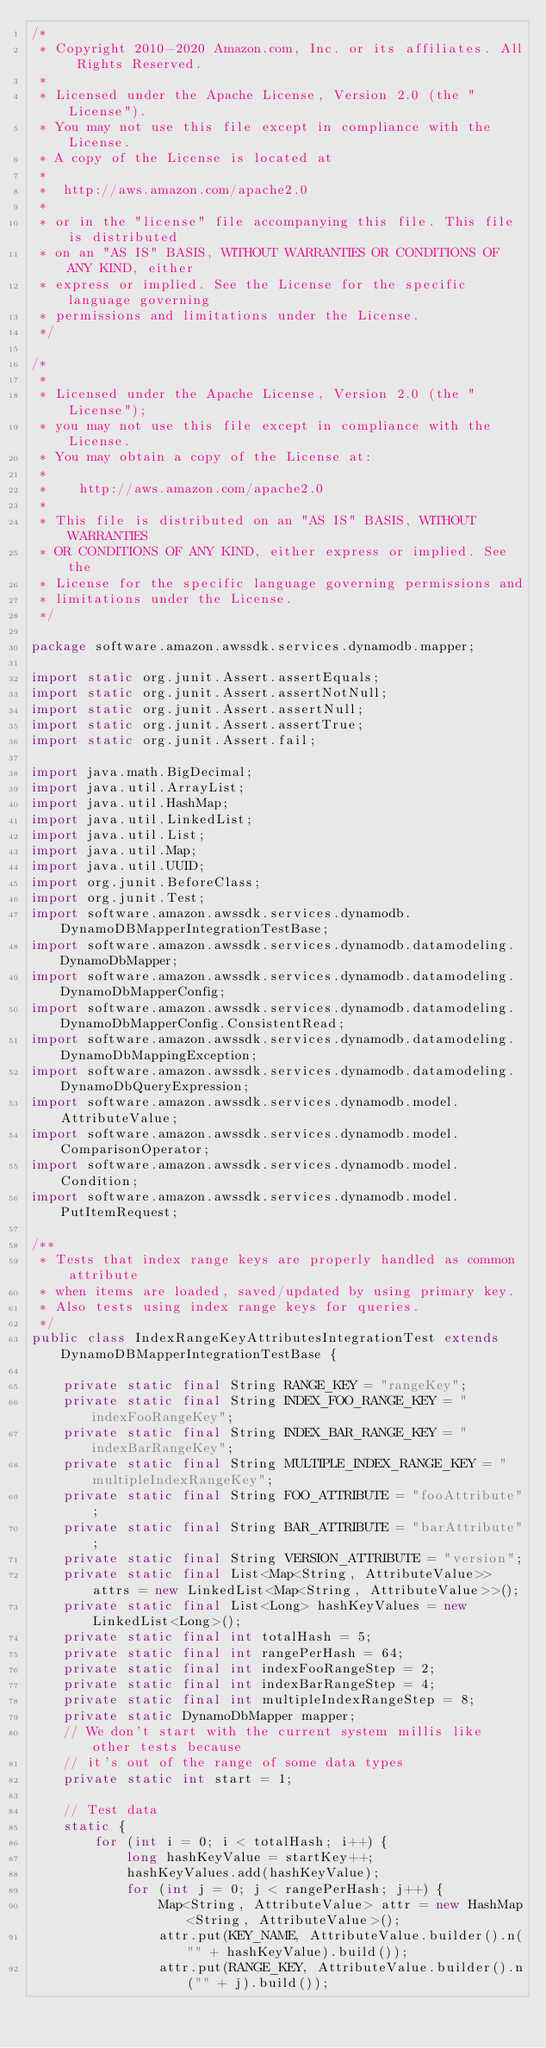Convert code to text. <code><loc_0><loc_0><loc_500><loc_500><_Java_>/*
 * Copyright 2010-2020 Amazon.com, Inc. or its affiliates. All Rights Reserved.
 *
 * Licensed under the Apache License, Version 2.0 (the "License").
 * You may not use this file except in compliance with the License.
 * A copy of the License is located at
 *
 *  http://aws.amazon.com/apache2.0
 *
 * or in the "license" file accompanying this file. This file is distributed
 * on an "AS IS" BASIS, WITHOUT WARRANTIES OR CONDITIONS OF ANY KIND, either
 * express or implied. See the License for the specific language governing
 * permissions and limitations under the License.
 */

/*
 *
 * Licensed under the Apache License, Version 2.0 (the "License");
 * you may not use this file except in compliance with the License.
 * You may obtain a copy of the License at:
 *
 *    http://aws.amazon.com/apache2.0
 *
 * This file is distributed on an "AS IS" BASIS, WITHOUT WARRANTIES
 * OR CONDITIONS OF ANY KIND, either express or implied. See the
 * License for the specific language governing permissions and
 * limitations under the License.
 */

package software.amazon.awssdk.services.dynamodb.mapper;

import static org.junit.Assert.assertEquals;
import static org.junit.Assert.assertNotNull;
import static org.junit.Assert.assertNull;
import static org.junit.Assert.assertTrue;
import static org.junit.Assert.fail;

import java.math.BigDecimal;
import java.util.ArrayList;
import java.util.HashMap;
import java.util.LinkedList;
import java.util.List;
import java.util.Map;
import java.util.UUID;
import org.junit.BeforeClass;
import org.junit.Test;
import software.amazon.awssdk.services.dynamodb.DynamoDBMapperIntegrationTestBase;
import software.amazon.awssdk.services.dynamodb.datamodeling.DynamoDbMapper;
import software.amazon.awssdk.services.dynamodb.datamodeling.DynamoDbMapperConfig;
import software.amazon.awssdk.services.dynamodb.datamodeling.DynamoDbMapperConfig.ConsistentRead;
import software.amazon.awssdk.services.dynamodb.datamodeling.DynamoDbMappingException;
import software.amazon.awssdk.services.dynamodb.datamodeling.DynamoDbQueryExpression;
import software.amazon.awssdk.services.dynamodb.model.AttributeValue;
import software.amazon.awssdk.services.dynamodb.model.ComparisonOperator;
import software.amazon.awssdk.services.dynamodb.model.Condition;
import software.amazon.awssdk.services.dynamodb.model.PutItemRequest;

/**
 * Tests that index range keys are properly handled as common attribute
 * when items are loaded, saved/updated by using primary key.
 * Also tests using index range keys for queries.
 */
public class IndexRangeKeyAttributesIntegrationTest extends DynamoDBMapperIntegrationTestBase {

    private static final String RANGE_KEY = "rangeKey";
    private static final String INDEX_FOO_RANGE_KEY = "indexFooRangeKey";
    private static final String INDEX_BAR_RANGE_KEY = "indexBarRangeKey";
    private static final String MULTIPLE_INDEX_RANGE_KEY = "multipleIndexRangeKey";
    private static final String FOO_ATTRIBUTE = "fooAttribute";
    private static final String BAR_ATTRIBUTE = "barAttribute";
    private static final String VERSION_ATTRIBUTE = "version";
    private static final List<Map<String, AttributeValue>> attrs = new LinkedList<Map<String, AttributeValue>>();
    private static final List<Long> hashKeyValues = new LinkedList<Long>();
    private static final int totalHash = 5;
    private static final int rangePerHash = 64;
    private static final int indexFooRangeStep = 2;
    private static final int indexBarRangeStep = 4;
    private static final int multipleIndexRangeStep = 8;
    private static DynamoDbMapper mapper;
    // We don't start with the current system millis like other tests because
    // it's out of the range of some data types
    private static int start = 1;

    // Test data
    static {
        for (int i = 0; i < totalHash; i++) {
            long hashKeyValue = startKey++;
            hashKeyValues.add(hashKeyValue);
            for (int j = 0; j < rangePerHash; j++) {
                Map<String, AttributeValue> attr = new HashMap<String, AttributeValue>();
                attr.put(KEY_NAME, AttributeValue.builder().n("" + hashKeyValue).build());
                attr.put(RANGE_KEY, AttributeValue.builder().n("" + j).build());</code> 